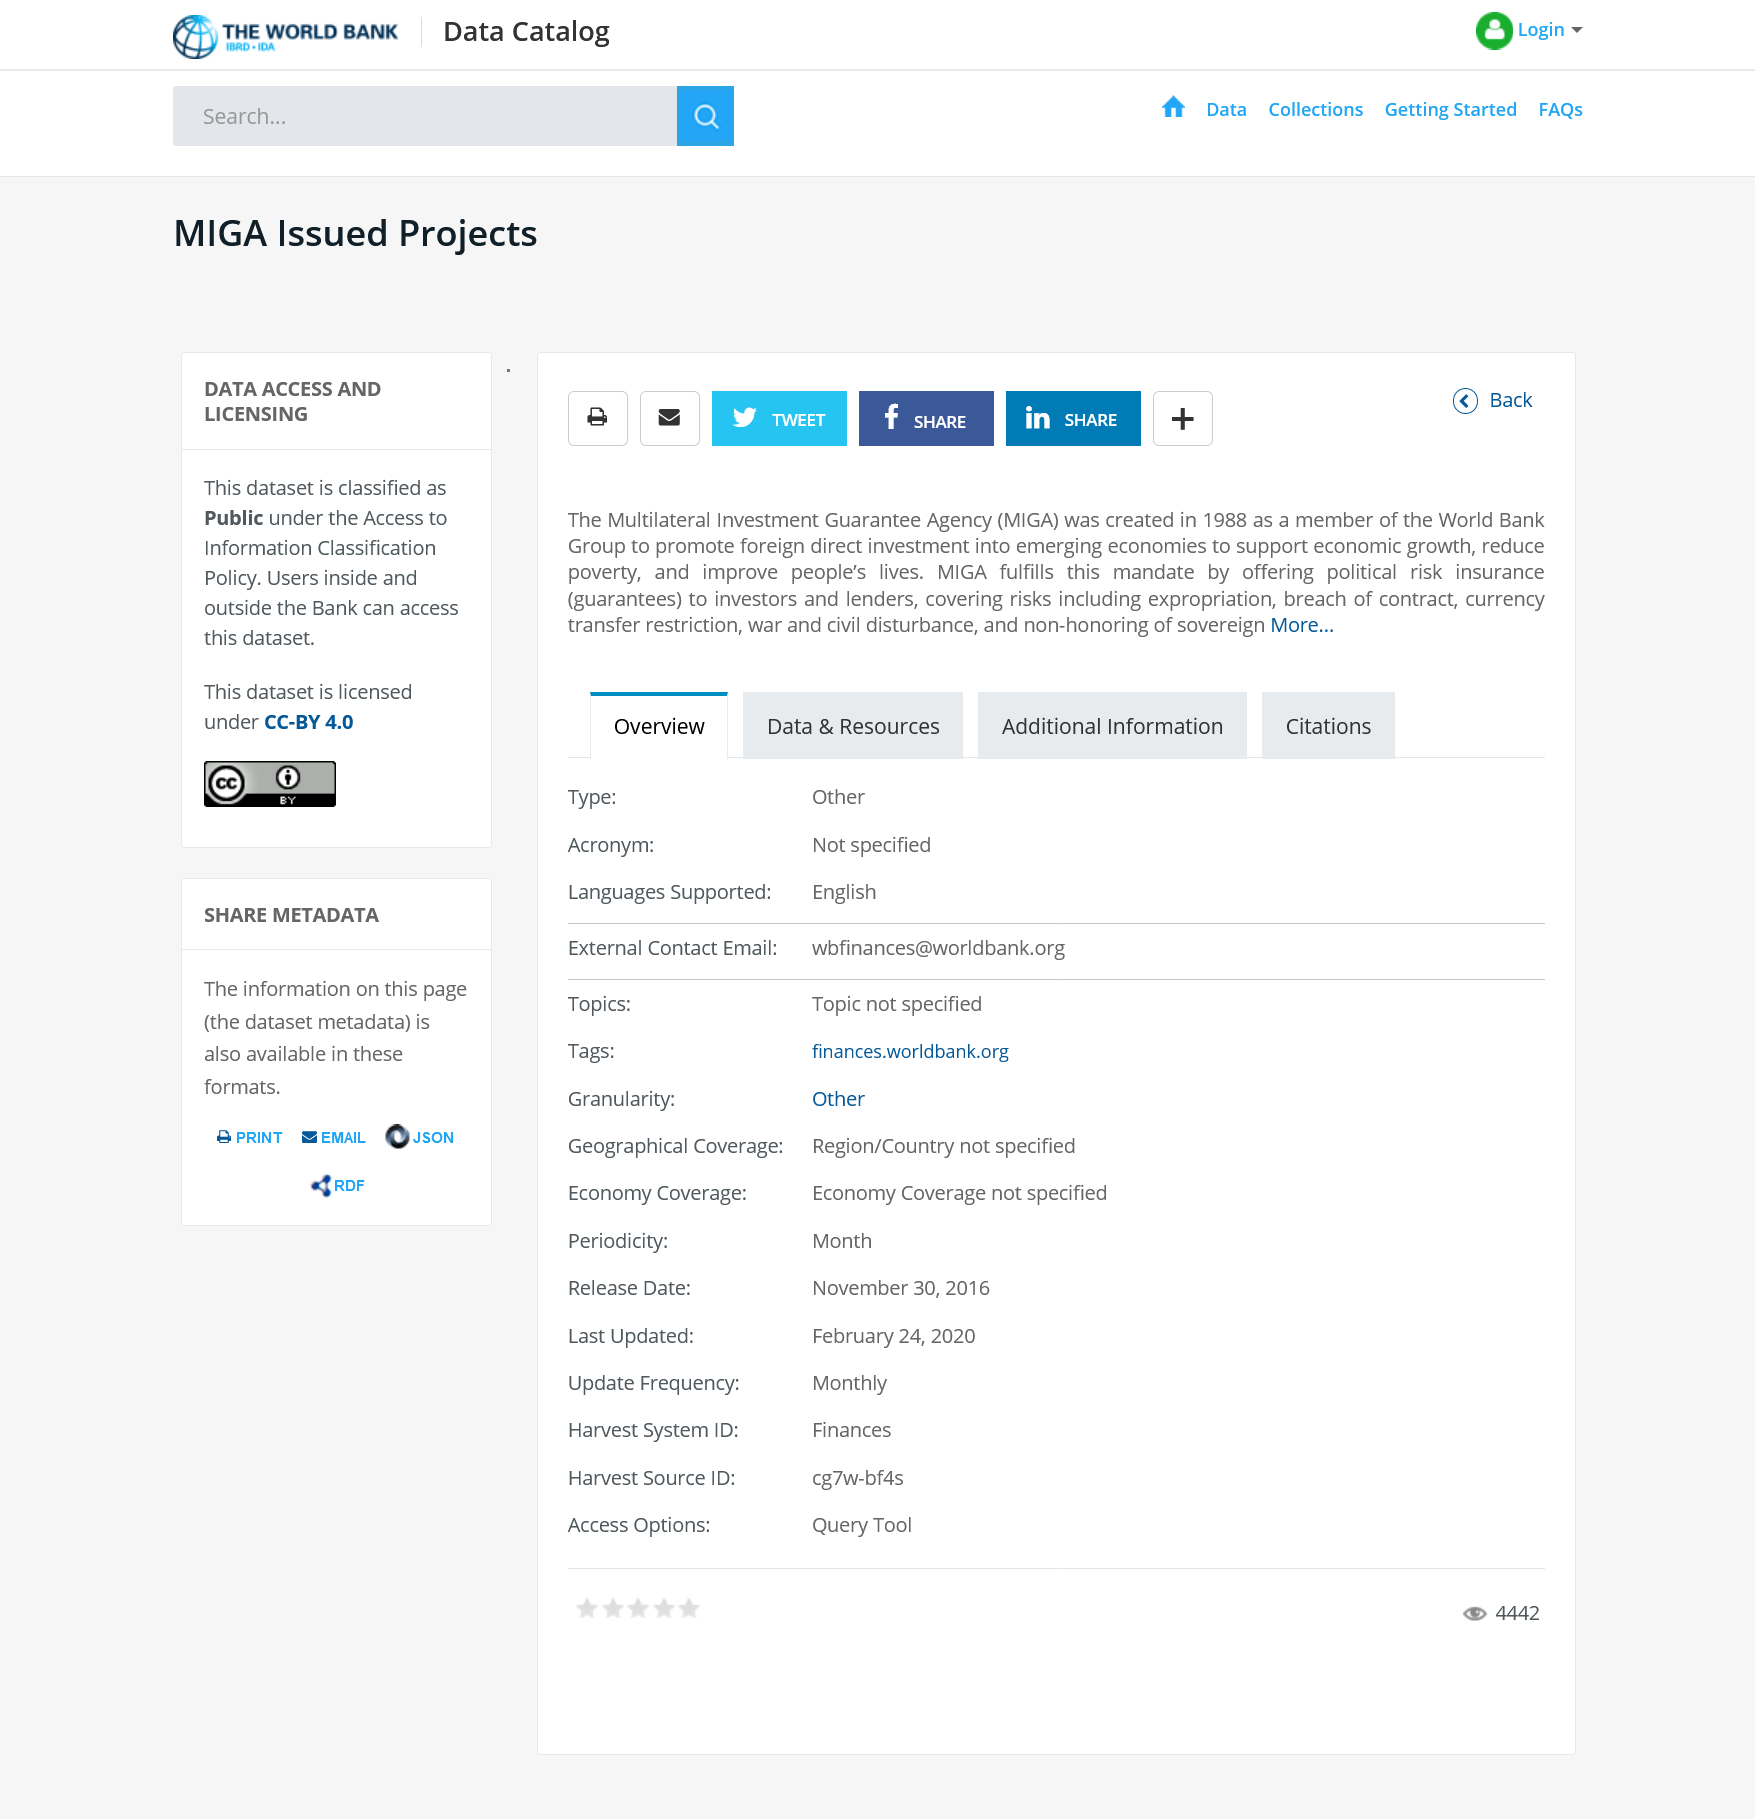Give some essential details in this illustration. The page provides the option to share the dataset on Facebook. Under the Access to Information Classification Policy, the dataset is classified as public. The MIGA was established in 1988. 